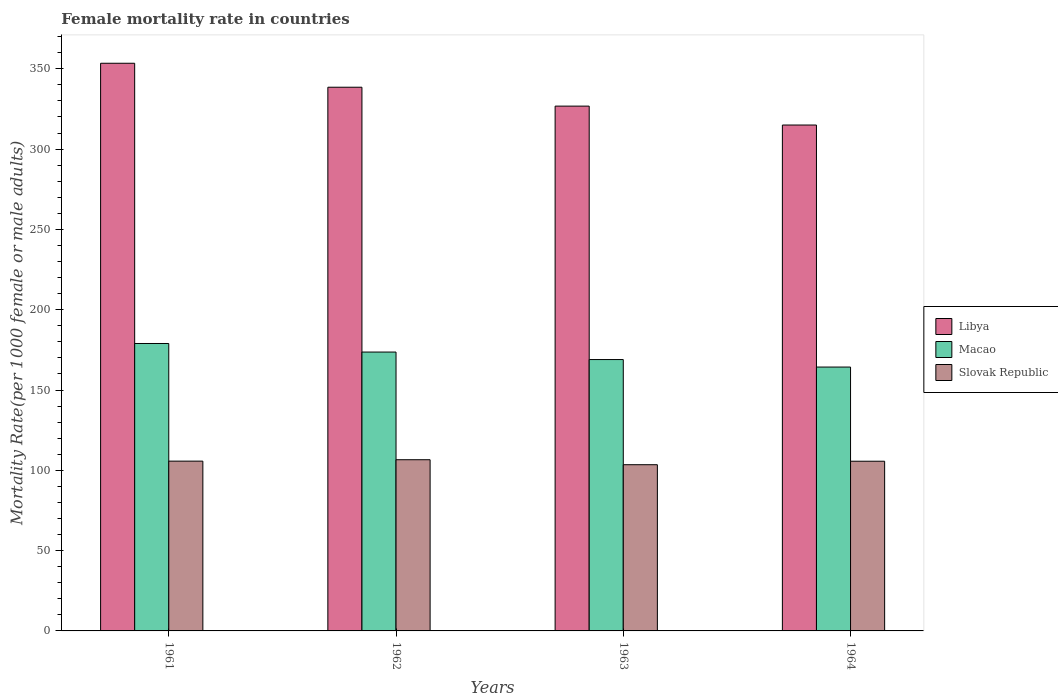How many different coloured bars are there?
Offer a very short reply. 3. How many groups of bars are there?
Offer a terse response. 4. Are the number of bars per tick equal to the number of legend labels?
Your answer should be compact. Yes. How many bars are there on the 1st tick from the left?
Provide a short and direct response. 3. How many bars are there on the 1st tick from the right?
Give a very brief answer. 3. What is the female mortality rate in Macao in 1961?
Your answer should be very brief. 178.97. Across all years, what is the maximum female mortality rate in Libya?
Offer a terse response. 353.46. Across all years, what is the minimum female mortality rate in Macao?
Your response must be concise. 164.29. In which year was the female mortality rate in Libya maximum?
Give a very brief answer. 1961. What is the total female mortality rate in Libya in the graph?
Make the answer very short. 1333.78. What is the difference between the female mortality rate in Macao in 1962 and that in 1964?
Your response must be concise. 9.35. What is the difference between the female mortality rate in Libya in 1962 and the female mortality rate in Macao in 1964?
Make the answer very short. 174.24. What is the average female mortality rate in Libya per year?
Provide a short and direct response. 333.44. In the year 1961, what is the difference between the female mortality rate in Slovak Republic and female mortality rate in Macao?
Provide a succinct answer. -73.24. What is the ratio of the female mortality rate in Slovak Republic in 1961 to that in 1963?
Keep it short and to the point. 1.02. Is the female mortality rate in Slovak Republic in 1961 less than that in 1964?
Ensure brevity in your answer.  No. Is the difference between the female mortality rate in Slovak Republic in 1961 and 1962 greater than the difference between the female mortality rate in Macao in 1961 and 1962?
Offer a terse response. No. What is the difference between the highest and the second highest female mortality rate in Slovak Republic?
Ensure brevity in your answer.  0.87. What is the difference between the highest and the lowest female mortality rate in Macao?
Make the answer very short. 14.67. Is the sum of the female mortality rate in Slovak Republic in 1962 and 1963 greater than the maximum female mortality rate in Macao across all years?
Make the answer very short. Yes. What does the 1st bar from the left in 1962 represents?
Keep it short and to the point. Libya. What does the 2nd bar from the right in 1963 represents?
Give a very brief answer. Macao. Is it the case that in every year, the sum of the female mortality rate in Slovak Republic and female mortality rate in Libya is greater than the female mortality rate in Macao?
Make the answer very short. Yes. How many bars are there?
Your answer should be very brief. 12. Does the graph contain any zero values?
Ensure brevity in your answer.  No. Does the graph contain grids?
Your answer should be very brief. No. Where does the legend appear in the graph?
Make the answer very short. Center right. What is the title of the graph?
Your answer should be compact. Female mortality rate in countries. Does "Norway" appear as one of the legend labels in the graph?
Your answer should be very brief. No. What is the label or title of the X-axis?
Keep it short and to the point. Years. What is the label or title of the Y-axis?
Your response must be concise. Mortality Rate(per 1000 female or male adults). What is the Mortality Rate(per 1000 female or male adults) in Libya in 1961?
Give a very brief answer. 353.46. What is the Mortality Rate(per 1000 female or male adults) in Macao in 1961?
Make the answer very short. 178.97. What is the Mortality Rate(per 1000 female or male adults) of Slovak Republic in 1961?
Your response must be concise. 105.72. What is the Mortality Rate(per 1000 female or male adults) in Libya in 1962?
Keep it short and to the point. 338.54. What is the Mortality Rate(per 1000 female or male adults) of Macao in 1962?
Keep it short and to the point. 173.64. What is the Mortality Rate(per 1000 female or male adults) in Slovak Republic in 1962?
Offer a very short reply. 106.6. What is the Mortality Rate(per 1000 female or male adults) in Libya in 1963?
Give a very brief answer. 326.77. What is the Mortality Rate(per 1000 female or male adults) in Macao in 1963?
Offer a terse response. 168.97. What is the Mortality Rate(per 1000 female or male adults) of Slovak Republic in 1963?
Your response must be concise. 103.5. What is the Mortality Rate(per 1000 female or male adults) in Libya in 1964?
Offer a very short reply. 315.01. What is the Mortality Rate(per 1000 female or male adults) in Macao in 1964?
Give a very brief answer. 164.29. What is the Mortality Rate(per 1000 female or male adults) in Slovak Republic in 1964?
Your answer should be very brief. 105.66. Across all years, what is the maximum Mortality Rate(per 1000 female or male adults) in Libya?
Offer a very short reply. 353.46. Across all years, what is the maximum Mortality Rate(per 1000 female or male adults) in Macao?
Provide a succinct answer. 178.97. Across all years, what is the maximum Mortality Rate(per 1000 female or male adults) in Slovak Republic?
Keep it short and to the point. 106.6. Across all years, what is the minimum Mortality Rate(per 1000 female or male adults) in Libya?
Give a very brief answer. 315.01. Across all years, what is the minimum Mortality Rate(per 1000 female or male adults) in Macao?
Your response must be concise. 164.29. Across all years, what is the minimum Mortality Rate(per 1000 female or male adults) in Slovak Republic?
Give a very brief answer. 103.5. What is the total Mortality Rate(per 1000 female or male adults) in Libya in the graph?
Offer a terse response. 1333.78. What is the total Mortality Rate(per 1000 female or male adults) in Macao in the graph?
Provide a succinct answer. 685.87. What is the total Mortality Rate(per 1000 female or male adults) of Slovak Republic in the graph?
Offer a very short reply. 421.48. What is the difference between the Mortality Rate(per 1000 female or male adults) in Libya in 1961 and that in 1962?
Offer a very short reply. 14.92. What is the difference between the Mortality Rate(per 1000 female or male adults) in Macao in 1961 and that in 1962?
Keep it short and to the point. 5.33. What is the difference between the Mortality Rate(per 1000 female or male adults) in Slovak Republic in 1961 and that in 1962?
Give a very brief answer. -0.87. What is the difference between the Mortality Rate(per 1000 female or male adults) in Libya in 1961 and that in 1963?
Provide a short and direct response. 26.69. What is the difference between the Mortality Rate(per 1000 female or male adults) in Slovak Republic in 1961 and that in 1963?
Give a very brief answer. 2.23. What is the difference between the Mortality Rate(per 1000 female or male adults) of Libya in 1961 and that in 1964?
Offer a very short reply. 38.45. What is the difference between the Mortality Rate(per 1000 female or male adults) in Macao in 1961 and that in 1964?
Ensure brevity in your answer.  14.67. What is the difference between the Mortality Rate(per 1000 female or male adults) in Slovak Republic in 1961 and that in 1964?
Provide a succinct answer. 0.06. What is the difference between the Mortality Rate(per 1000 female or male adults) of Libya in 1962 and that in 1963?
Offer a terse response. 11.77. What is the difference between the Mortality Rate(per 1000 female or male adults) in Macao in 1962 and that in 1963?
Your answer should be compact. 4.67. What is the difference between the Mortality Rate(per 1000 female or male adults) of Slovak Republic in 1962 and that in 1963?
Your answer should be compact. 3.1. What is the difference between the Mortality Rate(per 1000 female or male adults) in Libya in 1962 and that in 1964?
Give a very brief answer. 23.53. What is the difference between the Mortality Rate(per 1000 female or male adults) of Macao in 1962 and that in 1964?
Give a very brief answer. 9.35. What is the difference between the Mortality Rate(per 1000 female or male adults) of Slovak Republic in 1962 and that in 1964?
Ensure brevity in your answer.  0.93. What is the difference between the Mortality Rate(per 1000 female or male adults) in Libya in 1963 and that in 1964?
Make the answer very short. 11.77. What is the difference between the Mortality Rate(per 1000 female or male adults) of Macao in 1963 and that in 1964?
Provide a short and direct response. 4.67. What is the difference between the Mortality Rate(per 1000 female or male adults) of Slovak Republic in 1963 and that in 1964?
Provide a short and direct response. -2.17. What is the difference between the Mortality Rate(per 1000 female or male adults) in Libya in 1961 and the Mortality Rate(per 1000 female or male adults) in Macao in 1962?
Offer a very short reply. 179.82. What is the difference between the Mortality Rate(per 1000 female or male adults) in Libya in 1961 and the Mortality Rate(per 1000 female or male adults) in Slovak Republic in 1962?
Keep it short and to the point. 246.86. What is the difference between the Mortality Rate(per 1000 female or male adults) in Macao in 1961 and the Mortality Rate(per 1000 female or male adults) in Slovak Republic in 1962?
Offer a terse response. 72.37. What is the difference between the Mortality Rate(per 1000 female or male adults) of Libya in 1961 and the Mortality Rate(per 1000 female or male adults) of Macao in 1963?
Ensure brevity in your answer.  184.49. What is the difference between the Mortality Rate(per 1000 female or male adults) of Libya in 1961 and the Mortality Rate(per 1000 female or male adults) of Slovak Republic in 1963?
Provide a succinct answer. 249.96. What is the difference between the Mortality Rate(per 1000 female or male adults) of Macao in 1961 and the Mortality Rate(per 1000 female or male adults) of Slovak Republic in 1963?
Ensure brevity in your answer.  75.47. What is the difference between the Mortality Rate(per 1000 female or male adults) of Libya in 1961 and the Mortality Rate(per 1000 female or male adults) of Macao in 1964?
Keep it short and to the point. 189.17. What is the difference between the Mortality Rate(per 1000 female or male adults) of Libya in 1961 and the Mortality Rate(per 1000 female or male adults) of Slovak Republic in 1964?
Your answer should be very brief. 247.8. What is the difference between the Mortality Rate(per 1000 female or male adults) of Macao in 1961 and the Mortality Rate(per 1000 female or male adults) of Slovak Republic in 1964?
Your answer should be very brief. 73.3. What is the difference between the Mortality Rate(per 1000 female or male adults) in Libya in 1962 and the Mortality Rate(per 1000 female or male adults) in Macao in 1963?
Give a very brief answer. 169.57. What is the difference between the Mortality Rate(per 1000 female or male adults) in Libya in 1962 and the Mortality Rate(per 1000 female or male adults) in Slovak Republic in 1963?
Make the answer very short. 235.04. What is the difference between the Mortality Rate(per 1000 female or male adults) of Macao in 1962 and the Mortality Rate(per 1000 female or male adults) of Slovak Republic in 1963?
Make the answer very short. 70.14. What is the difference between the Mortality Rate(per 1000 female or male adults) in Libya in 1962 and the Mortality Rate(per 1000 female or male adults) in Macao in 1964?
Give a very brief answer. 174.25. What is the difference between the Mortality Rate(per 1000 female or male adults) in Libya in 1962 and the Mortality Rate(per 1000 female or male adults) in Slovak Republic in 1964?
Offer a terse response. 232.88. What is the difference between the Mortality Rate(per 1000 female or male adults) in Macao in 1962 and the Mortality Rate(per 1000 female or male adults) in Slovak Republic in 1964?
Your answer should be very brief. 67.98. What is the difference between the Mortality Rate(per 1000 female or male adults) in Libya in 1963 and the Mortality Rate(per 1000 female or male adults) in Macao in 1964?
Provide a succinct answer. 162.48. What is the difference between the Mortality Rate(per 1000 female or male adults) in Libya in 1963 and the Mortality Rate(per 1000 female or male adults) in Slovak Republic in 1964?
Your response must be concise. 221.11. What is the difference between the Mortality Rate(per 1000 female or male adults) in Macao in 1963 and the Mortality Rate(per 1000 female or male adults) in Slovak Republic in 1964?
Your response must be concise. 63.3. What is the average Mortality Rate(per 1000 female or male adults) of Libya per year?
Provide a succinct answer. 333.44. What is the average Mortality Rate(per 1000 female or male adults) in Macao per year?
Give a very brief answer. 171.47. What is the average Mortality Rate(per 1000 female or male adults) in Slovak Republic per year?
Offer a terse response. 105.37. In the year 1961, what is the difference between the Mortality Rate(per 1000 female or male adults) in Libya and Mortality Rate(per 1000 female or male adults) in Macao?
Ensure brevity in your answer.  174.49. In the year 1961, what is the difference between the Mortality Rate(per 1000 female or male adults) in Libya and Mortality Rate(per 1000 female or male adults) in Slovak Republic?
Make the answer very short. 247.74. In the year 1961, what is the difference between the Mortality Rate(per 1000 female or male adults) of Macao and Mortality Rate(per 1000 female or male adults) of Slovak Republic?
Your answer should be very brief. 73.24. In the year 1962, what is the difference between the Mortality Rate(per 1000 female or male adults) in Libya and Mortality Rate(per 1000 female or male adults) in Macao?
Your answer should be very brief. 164.9. In the year 1962, what is the difference between the Mortality Rate(per 1000 female or male adults) in Libya and Mortality Rate(per 1000 female or male adults) in Slovak Republic?
Ensure brevity in your answer.  231.94. In the year 1962, what is the difference between the Mortality Rate(per 1000 female or male adults) of Macao and Mortality Rate(per 1000 female or male adults) of Slovak Republic?
Your response must be concise. 67.04. In the year 1963, what is the difference between the Mortality Rate(per 1000 female or male adults) in Libya and Mortality Rate(per 1000 female or male adults) in Macao?
Ensure brevity in your answer.  157.81. In the year 1963, what is the difference between the Mortality Rate(per 1000 female or male adults) in Libya and Mortality Rate(per 1000 female or male adults) in Slovak Republic?
Keep it short and to the point. 223.28. In the year 1963, what is the difference between the Mortality Rate(per 1000 female or male adults) of Macao and Mortality Rate(per 1000 female or male adults) of Slovak Republic?
Make the answer very short. 65.47. In the year 1964, what is the difference between the Mortality Rate(per 1000 female or male adults) in Libya and Mortality Rate(per 1000 female or male adults) in Macao?
Offer a very short reply. 150.71. In the year 1964, what is the difference between the Mortality Rate(per 1000 female or male adults) of Libya and Mortality Rate(per 1000 female or male adults) of Slovak Republic?
Your response must be concise. 209.34. In the year 1964, what is the difference between the Mortality Rate(per 1000 female or male adults) of Macao and Mortality Rate(per 1000 female or male adults) of Slovak Republic?
Provide a succinct answer. 58.63. What is the ratio of the Mortality Rate(per 1000 female or male adults) of Libya in 1961 to that in 1962?
Offer a terse response. 1.04. What is the ratio of the Mortality Rate(per 1000 female or male adults) of Macao in 1961 to that in 1962?
Your answer should be very brief. 1.03. What is the ratio of the Mortality Rate(per 1000 female or male adults) in Libya in 1961 to that in 1963?
Keep it short and to the point. 1.08. What is the ratio of the Mortality Rate(per 1000 female or male adults) of Macao in 1961 to that in 1963?
Ensure brevity in your answer.  1.06. What is the ratio of the Mortality Rate(per 1000 female or male adults) in Slovak Republic in 1961 to that in 1963?
Your answer should be compact. 1.02. What is the ratio of the Mortality Rate(per 1000 female or male adults) in Libya in 1961 to that in 1964?
Provide a succinct answer. 1.12. What is the ratio of the Mortality Rate(per 1000 female or male adults) of Macao in 1961 to that in 1964?
Give a very brief answer. 1.09. What is the ratio of the Mortality Rate(per 1000 female or male adults) in Slovak Republic in 1961 to that in 1964?
Give a very brief answer. 1. What is the ratio of the Mortality Rate(per 1000 female or male adults) of Libya in 1962 to that in 1963?
Keep it short and to the point. 1.04. What is the ratio of the Mortality Rate(per 1000 female or male adults) of Macao in 1962 to that in 1963?
Keep it short and to the point. 1.03. What is the ratio of the Mortality Rate(per 1000 female or male adults) of Slovak Republic in 1962 to that in 1963?
Your response must be concise. 1.03. What is the ratio of the Mortality Rate(per 1000 female or male adults) in Libya in 1962 to that in 1964?
Provide a succinct answer. 1.07. What is the ratio of the Mortality Rate(per 1000 female or male adults) of Macao in 1962 to that in 1964?
Provide a short and direct response. 1.06. What is the ratio of the Mortality Rate(per 1000 female or male adults) in Slovak Republic in 1962 to that in 1964?
Give a very brief answer. 1.01. What is the ratio of the Mortality Rate(per 1000 female or male adults) of Libya in 1963 to that in 1964?
Your response must be concise. 1.04. What is the ratio of the Mortality Rate(per 1000 female or male adults) in Macao in 1963 to that in 1964?
Give a very brief answer. 1.03. What is the ratio of the Mortality Rate(per 1000 female or male adults) in Slovak Republic in 1963 to that in 1964?
Your answer should be very brief. 0.98. What is the difference between the highest and the second highest Mortality Rate(per 1000 female or male adults) of Libya?
Your response must be concise. 14.92. What is the difference between the highest and the second highest Mortality Rate(per 1000 female or male adults) in Macao?
Give a very brief answer. 5.33. What is the difference between the highest and the second highest Mortality Rate(per 1000 female or male adults) in Slovak Republic?
Your answer should be compact. 0.87. What is the difference between the highest and the lowest Mortality Rate(per 1000 female or male adults) in Libya?
Your answer should be very brief. 38.45. What is the difference between the highest and the lowest Mortality Rate(per 1000 female or male adults) of Macao?
Give a very brief answer. 14.67. What is the difference between the highest and the lowest Mortality Rate(per 1000 female or male adults) of Slovak Republic?
Give a very brief answer. 3.1. 